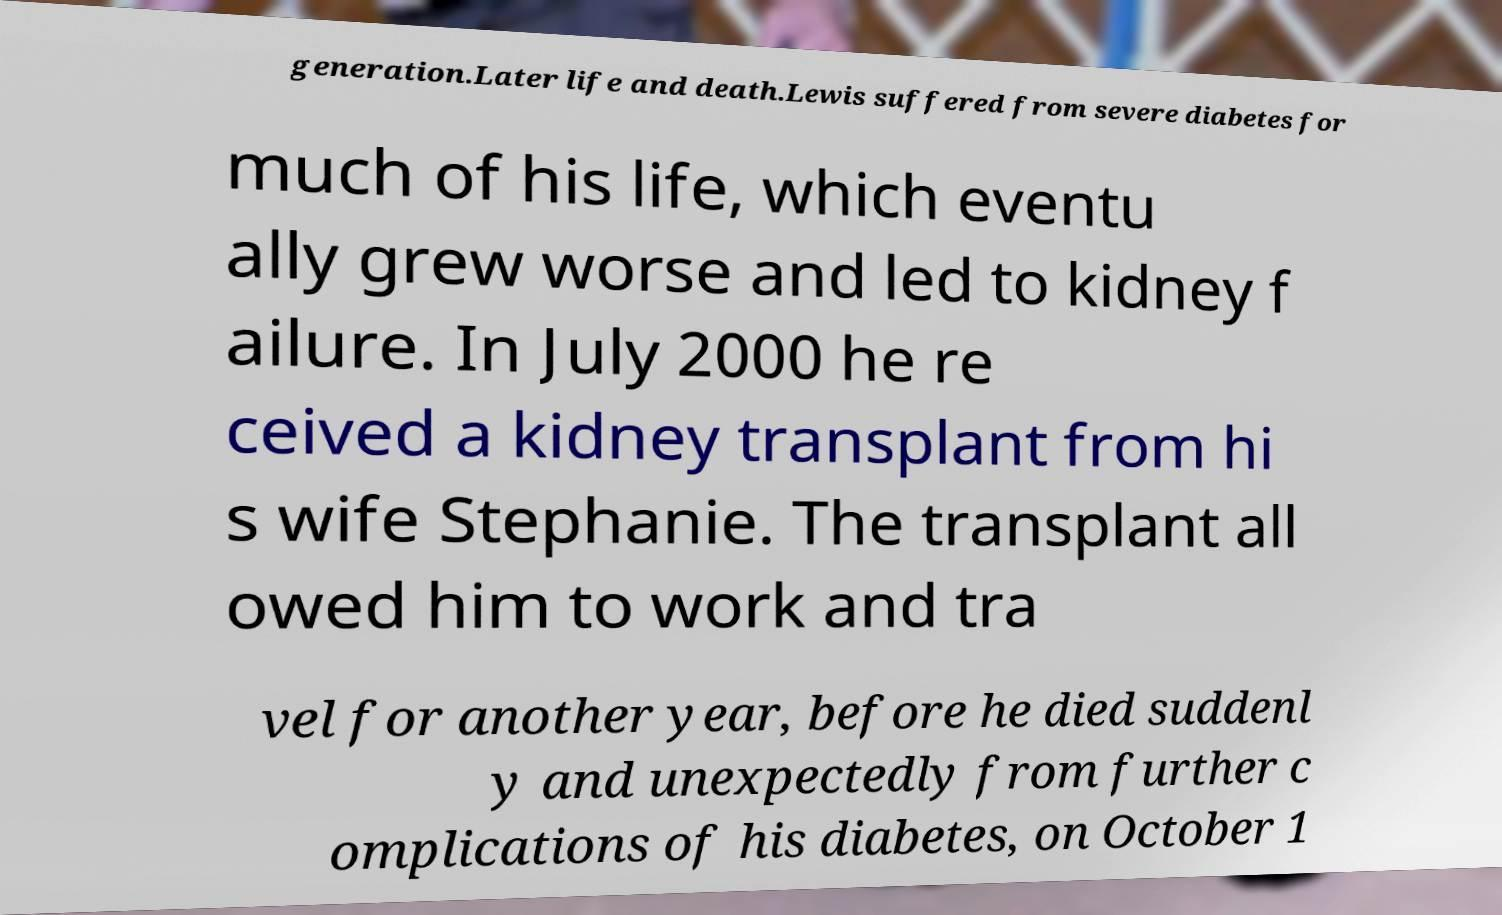What messages or text are displayed in this image? I need them in a readable, typed format. generation.Later life and death.Lewis suffered from severe diabetes for much of his life, which eventu ally grew worse and led to kidney f ailure. In July 2000 he re ceived a kidney transplant from hi s wife Stephanie. The transplant all owed him to work and tra vel for another year, before he died suddenl y and unexpectedly from further c omplications of his diabetes, on October 1 